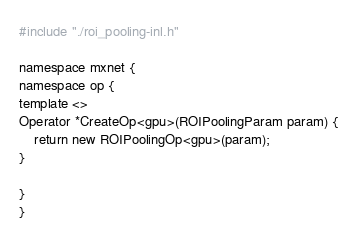Convert code to text. <code><loc_0><loc_0><loc_500><loc_500><_Cuda_>#include "./roi_pooling-inl.h"

namespace mxnet {
namespace op {
template <>
Operator *CreateOp<gpu>(ROIPoolingParam param) {
	return new ROIPoolingOp<gpu>(param);
}

}
}
</code> 